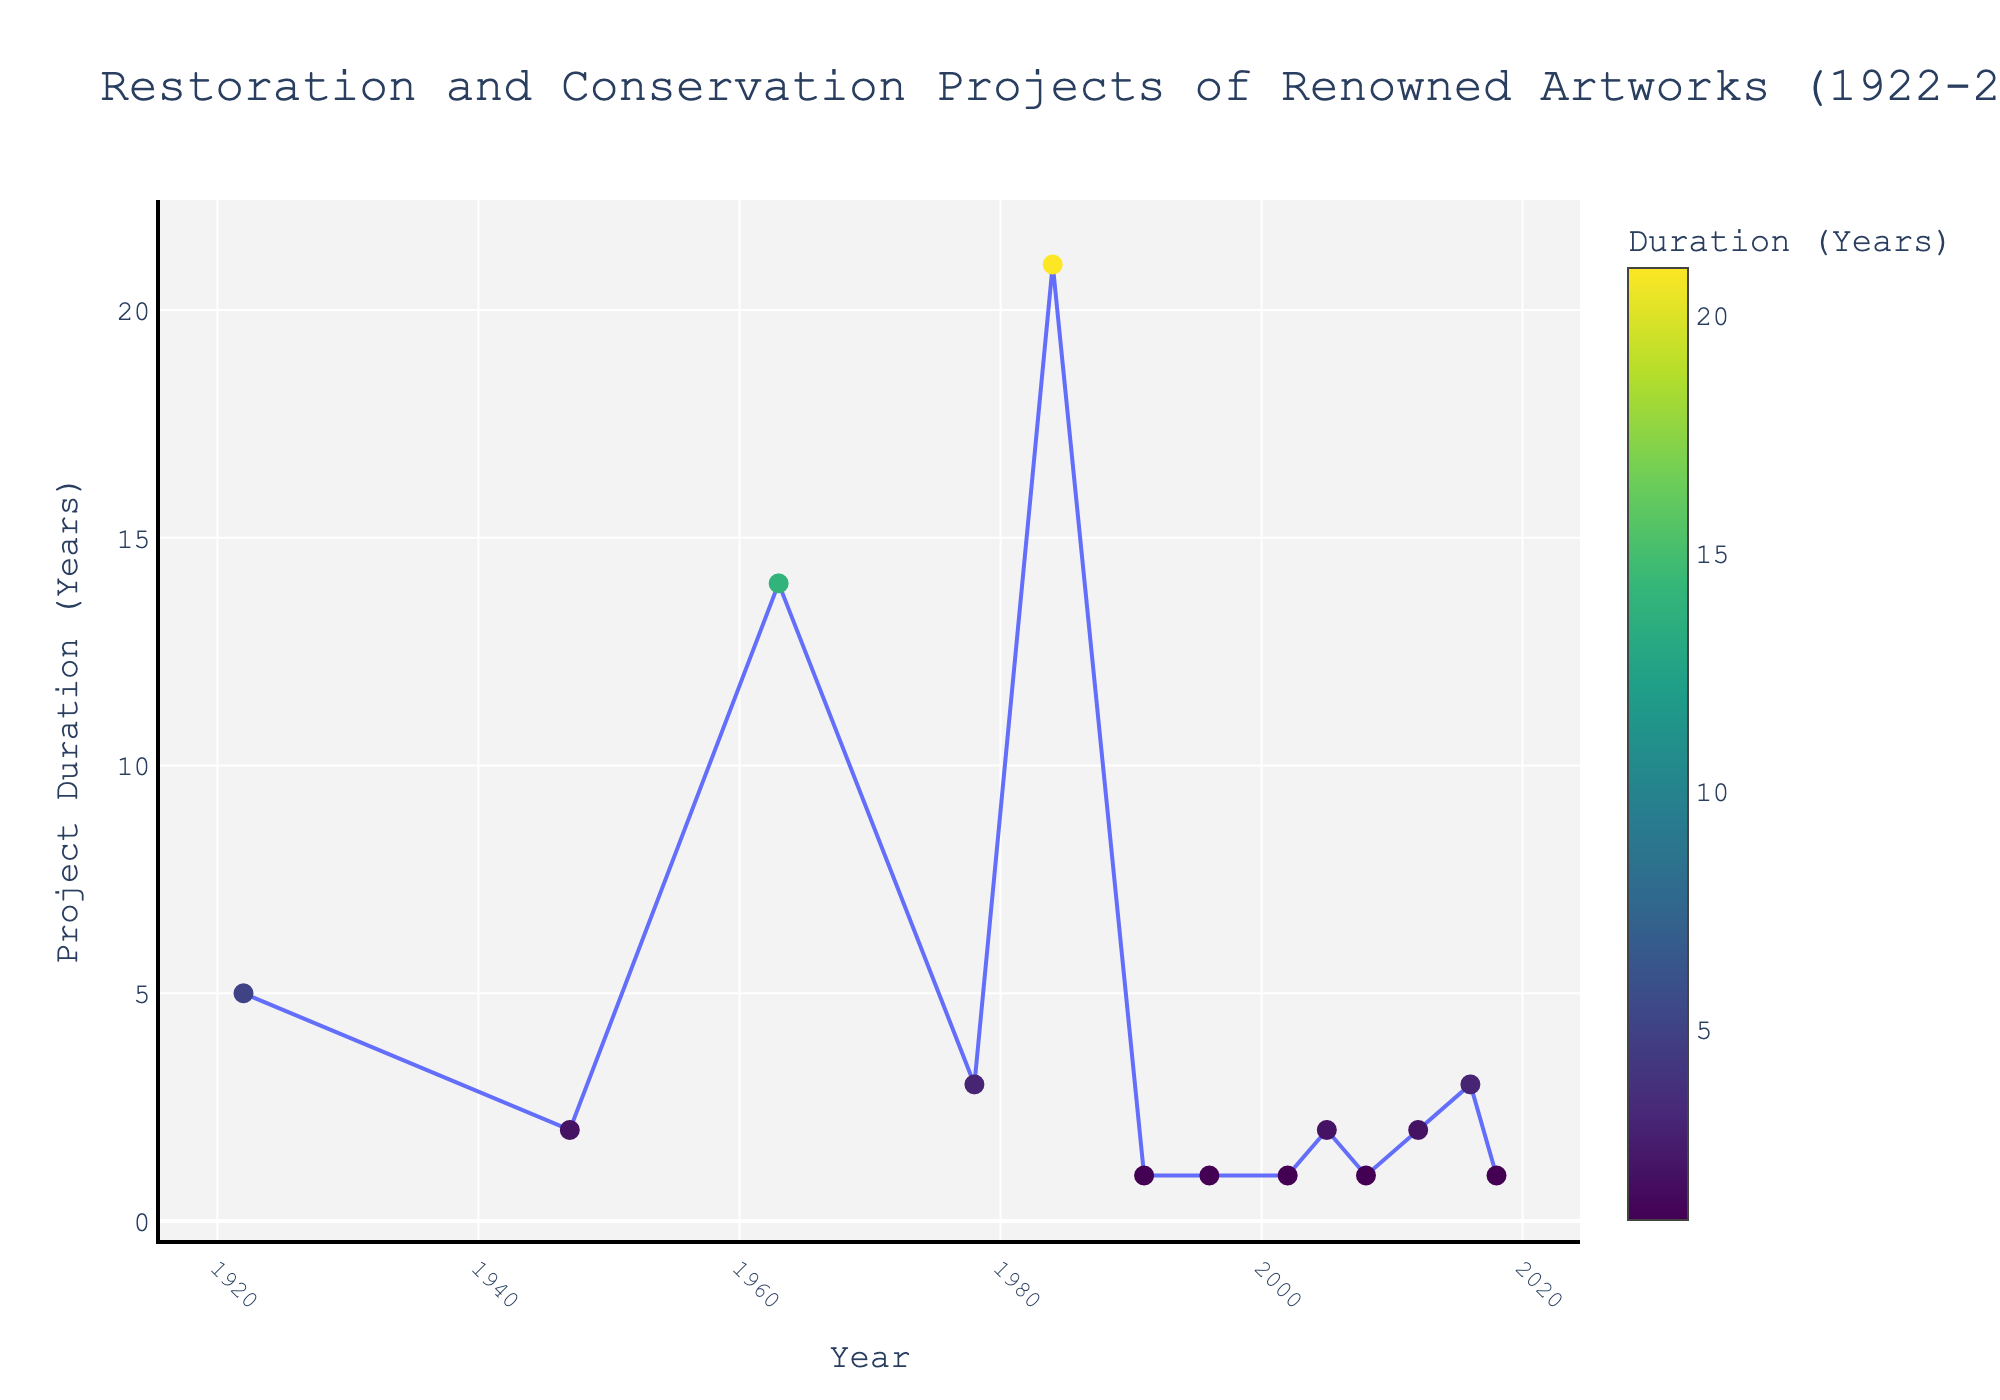Which artwork had the longest restoration project? Look at the data points on the y-axis to find the highest value, then refer to the hover text to identify which artwork that corresponds to.
Answer: The Last Supper by Leonardo da Vinci How many artworks had a restoration project duration of 1 year? Count the number of data points at the 1-year mark on the y-axis.
Answer: 6 What is the total duration of all restoration projects combined? Sum all values of 'RestorationProjectDurationYears' from each data point.
Answer: 56 years Which artist had two artworks with restoration projects listed in the figure? Check the hover texts for artists' names and identify any artist mentioned twice.
Answer: Leonardo da Vinci Which decade saw a restoration project that lasted 14 years? Look at the x-axis to find the decade and check the corresponding y-value.
Answer: 1960s How does the average duration of restoration projects compare before and after 1980? Calculate the average duration of projects before and after the 1980 mark and compare the two values.
Answer: Before 1980: 9 years; After 1980: 1.75 years Which project in the 1990s had the shortest restoration duration? Identify the project(s) with data points in the 1990s on the x-axis and compare their y-values to find the smallest one.
Answer: Guernica by Pablo Picasso What trend can be observed in the duration of restoration projects over the century? Observe the overall pattern in the plot from left to right, noting any increases or decreases in project durations.
Answer: Duration generally decreased over time Between 2000 and 2018, which artwork had the longest restoration duration? Look at data points between 2000 and 2018 on the x-axis and find the highest corresponding y-value.
Answer: The Persistence of Memory by Salvador Dalí How many projects had a duration longer than 5 years? Count the number of data points above the 5-year mark on the y-axis.
Answer: 2 